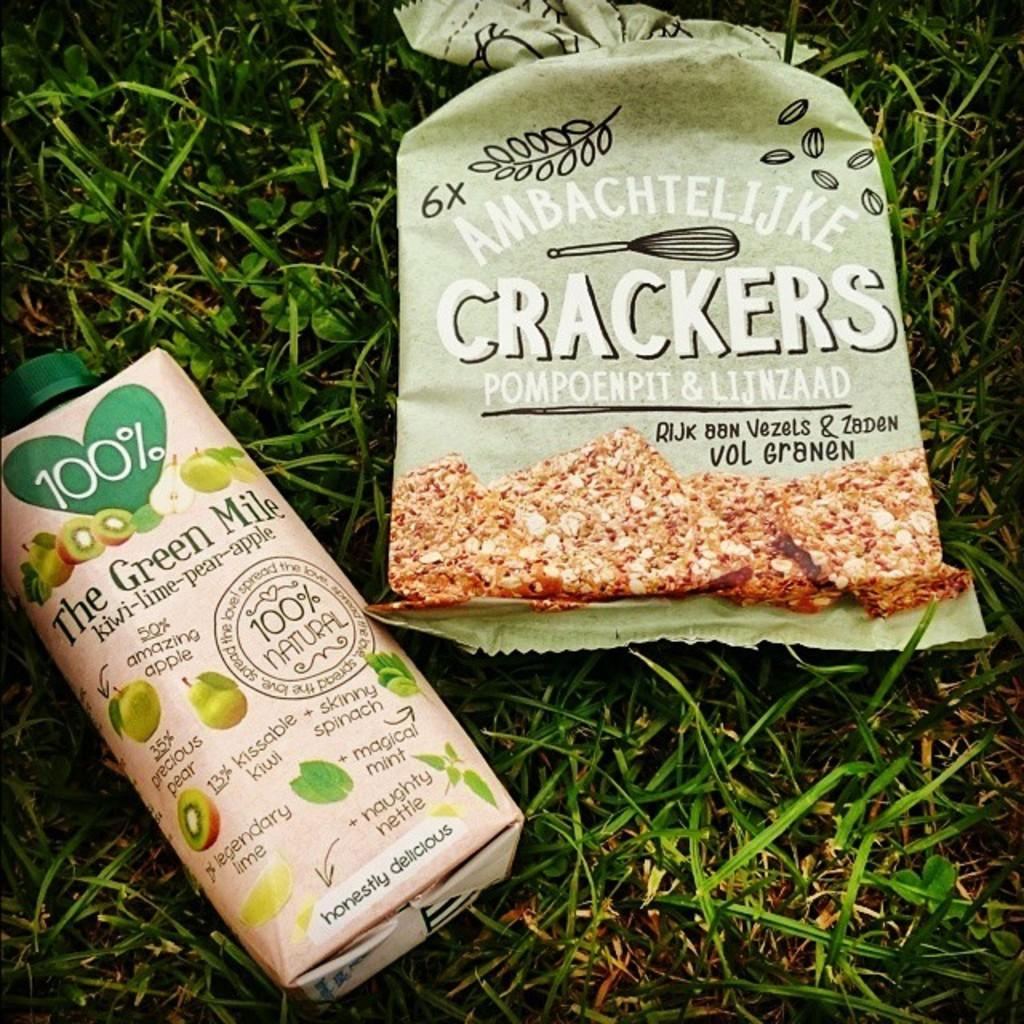<image>
Relay a brief, clear account of the picture shown. A bag of crackers is next to a drink bottle. 